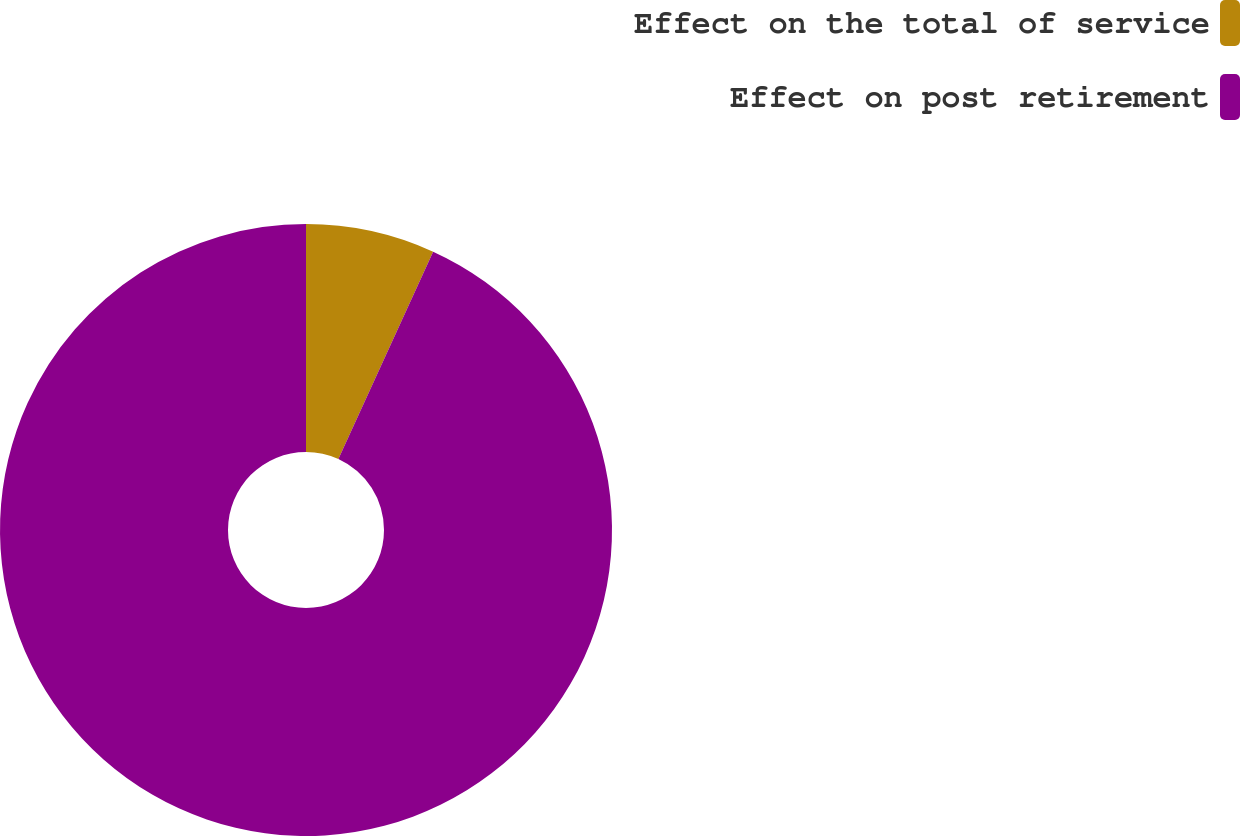Convert chart. <chart><loc_0><loc_0><loc_500><loc_500><pie_chart><fcel>Effect on the total of service<fcel>Effect on post retirement<nl><fcel>6.82%<fcel>93.18%<nl></chart> 